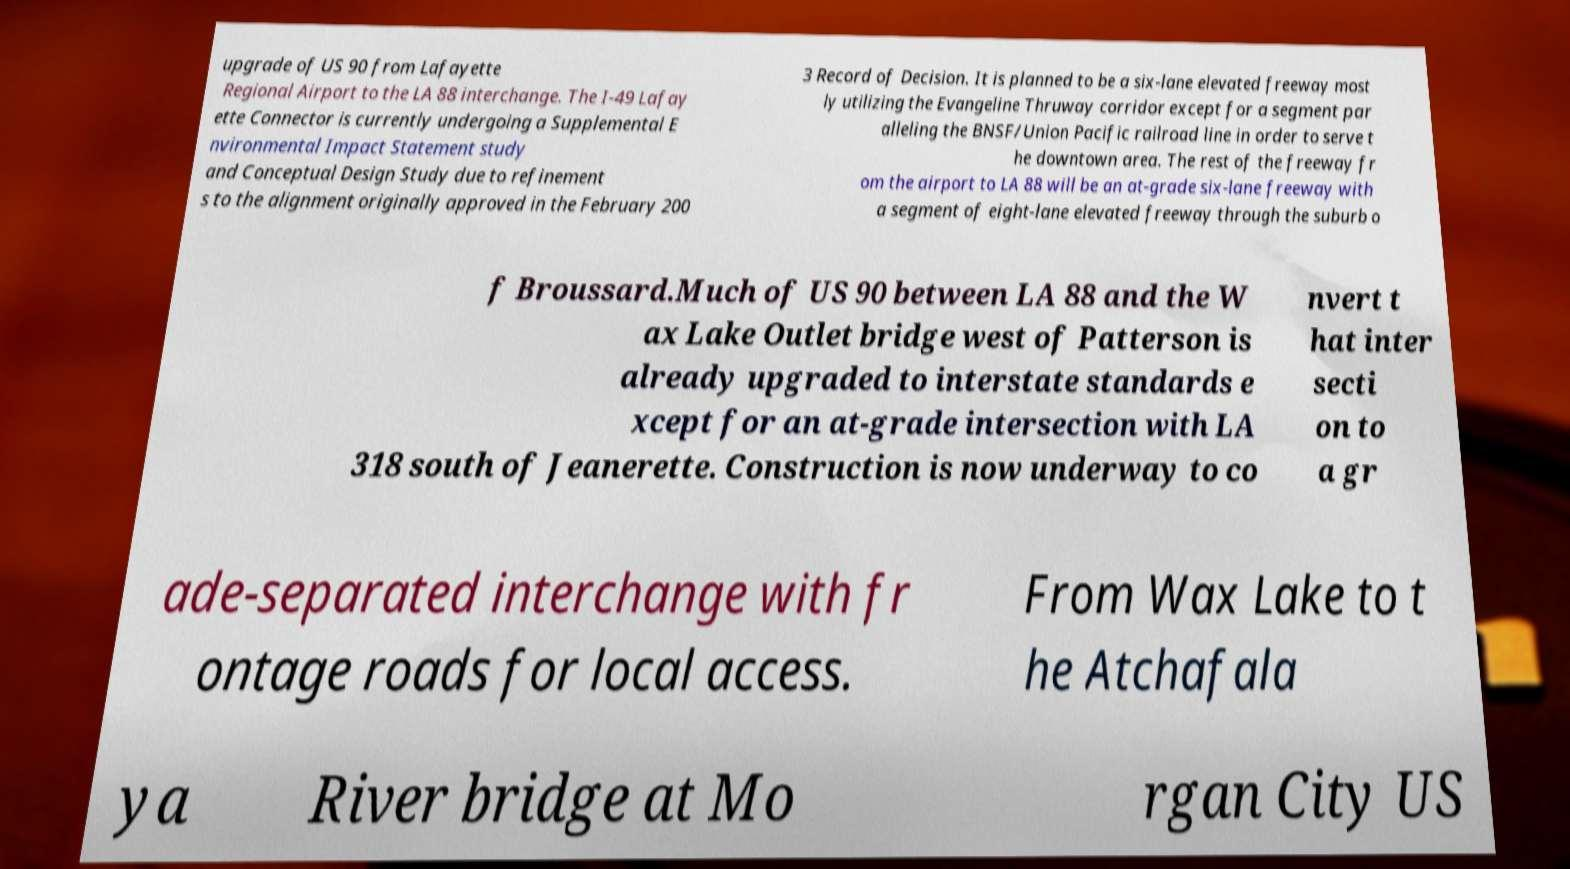There's text embedded in this image that I need extracted. Can you transcribe it verbatim? upgrade of US 90 from Lafayette Regional Airport to the LA 88 interchange. The I-49 Lafay ette Connector is currently undergoing a Supplemental E nvironmental Impact Statement study and Conceptual Design Study due to refinement s to the alignment originally approved in the February 200 3 Record of Decision. It is planned to be a six-lane elevated freeway most ly utilizing the Evangeline Thruway corridor except for a segment par alleling the BNSF/Union Pacific railroad line in order to serve t he downtown area. The rest of the freeway fr om the airport to LA 88 will be an at-grade six-lane freeway with a segment of eight-lane elevated freeway through the suburb o f Broussard.Much of US 90 between LA 88 and the W ax Lake Outlet bridge west of Patterson is already upgraded to interstate standards e xcept for an at-grade intersection with LA 318 south of Jeanerette. Construction is now underway to co nvert t hat inter secti on to a gr ade-separated interchange with fr ontage roads for local access. From Wax Lake to t he Atchafala ya River bridge at Mo rgan City US 